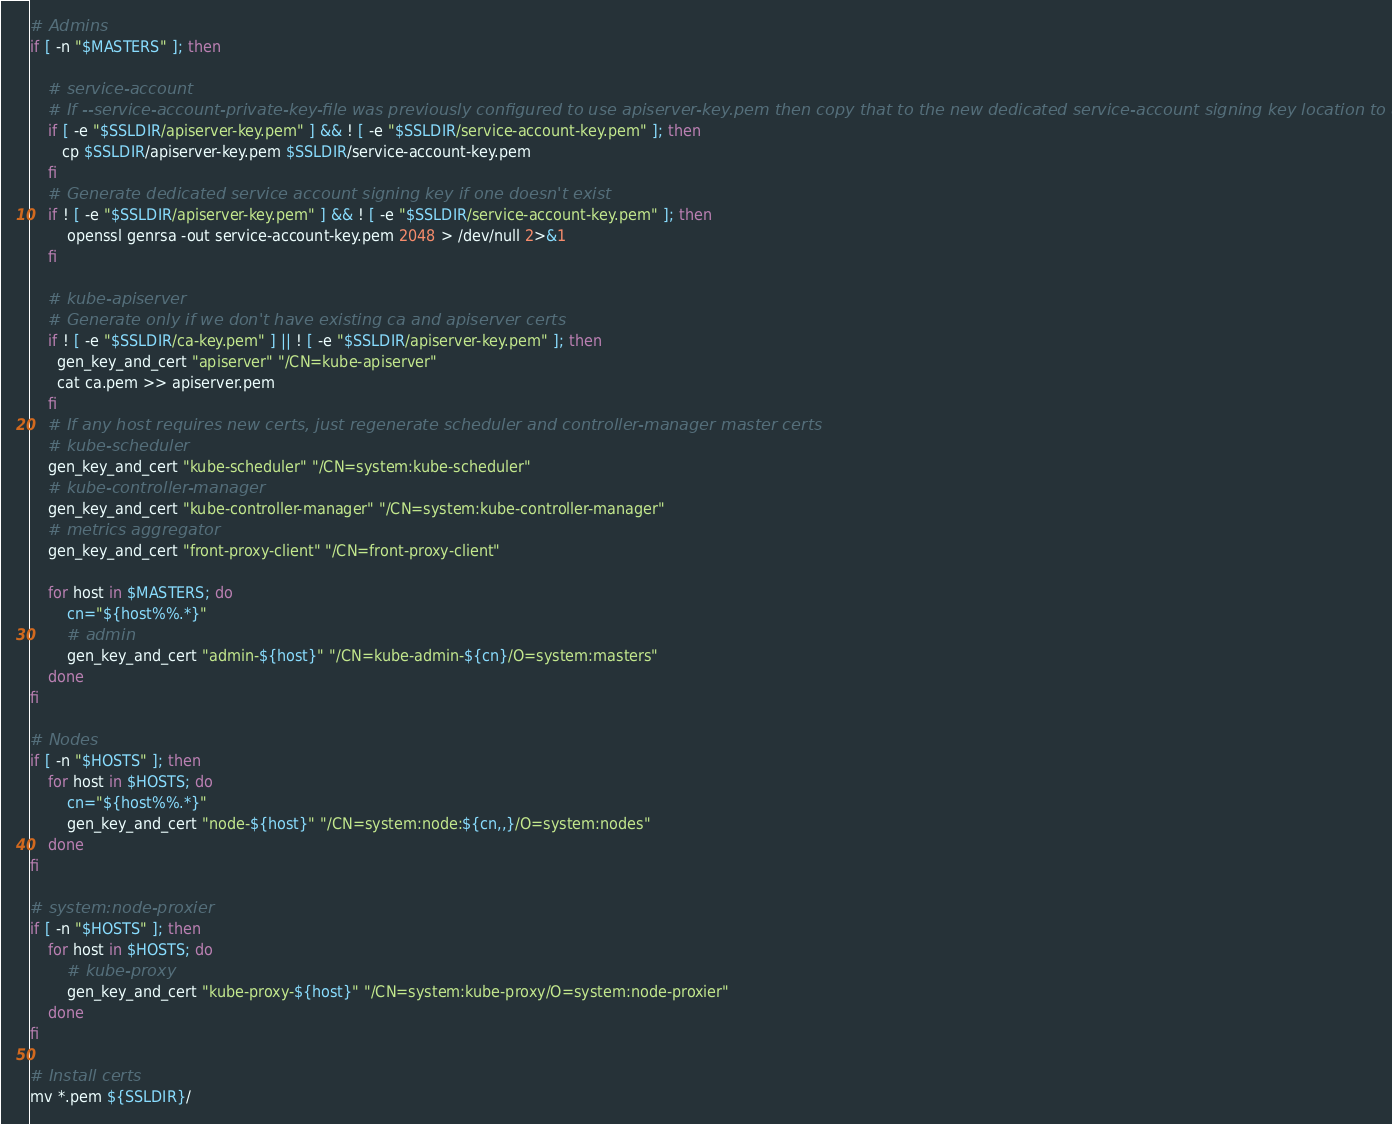<code> <loc_0><loc_0><loc_500><loc_500><_Bash_># Admins
if [ -n "$MASTERS" ]; then

    # service-account
    # If --service-account-private-key-file was previously configured to use apiserver-key.pem then copy that to the new dedicated service-account signing key location to avoid disruptions
    if [ -e "$SSLDIR/apiserver-key.pem" ] && ! [ -e "$SSLDIR/service-account-key.pem" ]; then
       cp $SSLDIR/apiserver-key.pem $SSLDIR/service-account-key.pem
    fi
    # Generate dedicated service account signing key if one doesn't exist
    if ! [ -e "$SSLDIR/apiserver-key.pem" ] && ! [ -e "$SSLDIR/service-account-key.pem" ]; then
        openssl genrsa -out service-account-key.pem 2048 > /dev/null 2>&1
    fi

    # kube-apiserver
    # Generate only if we don't have existing ca and apiserver certs
    if ! [ -e "$SSLDIR/ca-key.pem" ] || ! [ -e "$SSLDIR/apiserver-key.pem" ]; then
      gen_key_and_cert "apiserver" "/CN=kube-apiserver"
      cat ca.pem >> apiserver.pem
    fi
    # If any host requires new certs, just regenerate scheduler and controller-manager master certs
    # kube-scheduler
    gen_key_and_cert "kube-scheduler" "/CN=system:kube-scheduler"
    # kube-controller-manager
    gen_key_and_cert "kube-controller-manager" "/CN=system:kube-controller-manager"
    # metrics aggregator
    gen_key_and_cert "front-proxy-client" "/CN=front-proxy-client"

    for host in $MASTERS; do
        cn="${host%%.*}"
        # admin
        gen_key_and_cert "admin-${host}" "/CN=kube-admin-${cn}/O=system:masters"
    done
fi

# Nodes
if [ -n "$HOSTS" ]; then
    for host in $HOSTS; do
        cn="${host%%.*}"
        gen_key_and_cert "node-${host}" "/CN=system:node:${cn,,}/O=system:nodes"
    done
fi

# system:node-proxier
if [ -n "$HOSTS" ]; then
    for host in $HOSTS; do
        # kube-proxy
        gen_key_and_cert "kube-proxy-${host}" "/CN=system:kube-proxy/O=system:node-proxier"
    done
fi

# Install certs
mv *.pem ${SSLDIR}/
</code> 